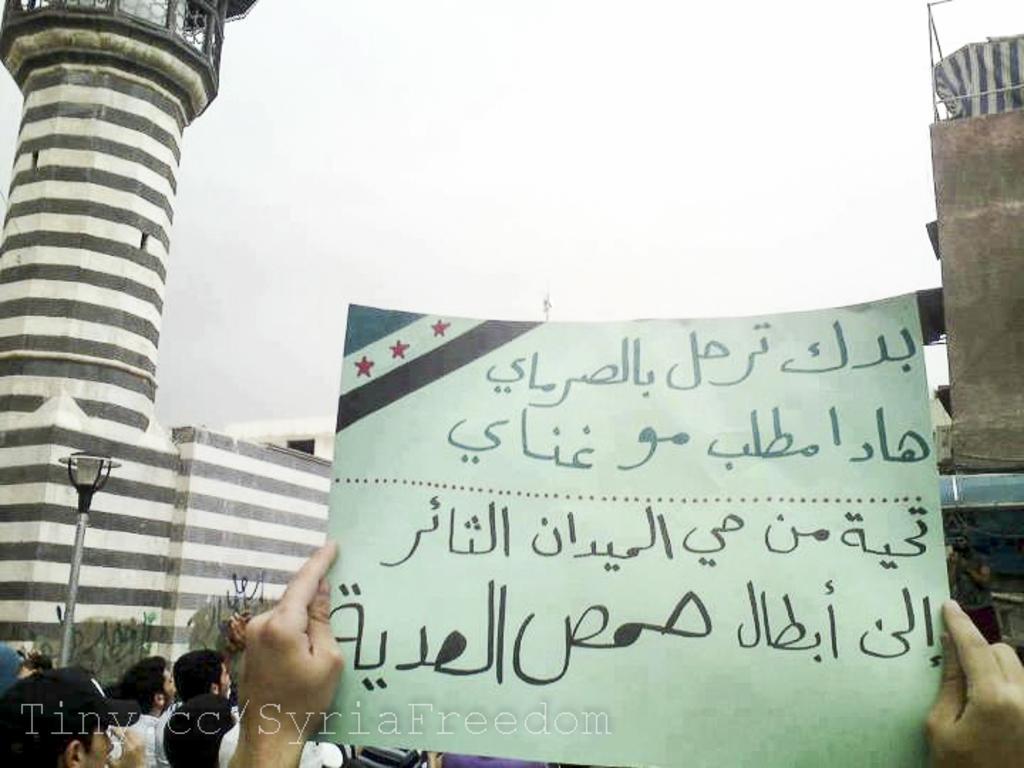Can you describe this image briefly? In this image in the front there is a banner with some text written on it, which is holded by the person. In the center there are persons, there is a pole. In the background there is a tower and there is a wall. On the right side there is a building and on the top of the building there is a tent. 